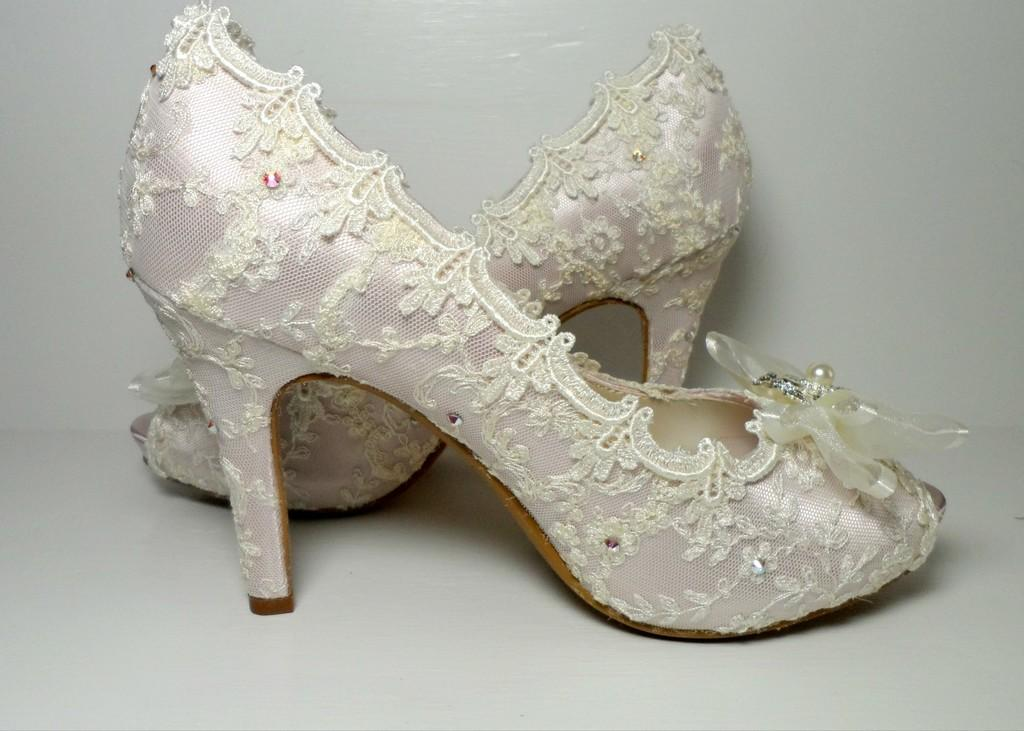What type of footwear is visible in the image? There are sandals in the image. What color is the surface at the bottom of the image? The surface at the bottom of the image is white. What type of business is being conducted in the image? There is no indication of any business being conducted in the image; it only features sandals and a white surface. 